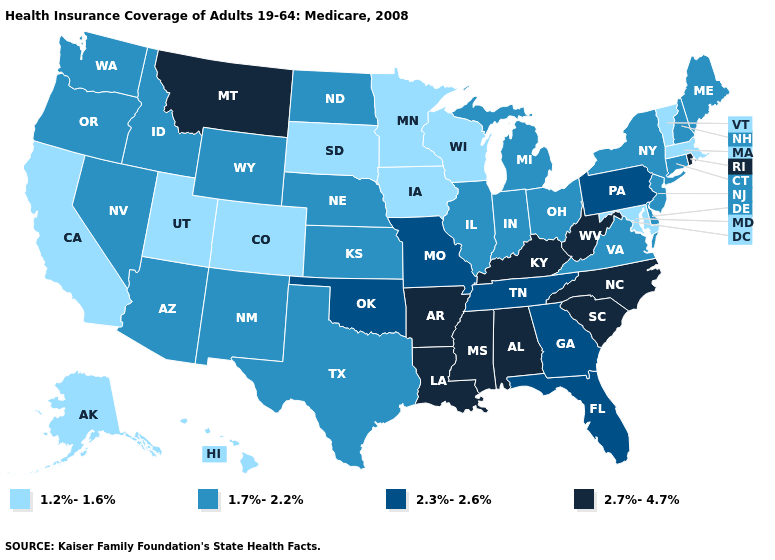What is the lowest value in the USA?
Keep it brief. 1.2%-1.6%. What is the value of Michigan?
Write a very short answer. 1.7%-2.2%. What is the highest value in states that border Oklahoma?
Keep it brief. 2.7%-4.7%. What is the value of Connecticut?
Concise answer only. 1.7%-2.2%. What is the value of Arizona?
Write a very short answer. 1.7%-2.2%. What is the highest value in states that border Vermont?
Write a very short answer. 1.7%-2.2%. Does the map have missing data?
Keep it brief. No. Name the states that have a value in the range 1.2%-1.6%?
Short answer required. Alaska, California, Colorado, Hawaii, Iowa, Maryland, Massachusetts, Minnesota, South Dakota, Utah, Vermont, Wisconsin. Does Delaware have the highest value in the South?
Give a very brief answer. No. What is the value of Minnesota?
Concise answer only. 1.2%-1.6%. What is the value of Mississippi?
Answer briefly. 2.7%-4.7%. Does the map have missing data?
Short answer required. No. Does the first symbol in the legend represent the smallest category?
Quick response, please. Yes. What is the lowest value in states that border Kentucky?
Write a very short answer. 1.7%-2.2%. 